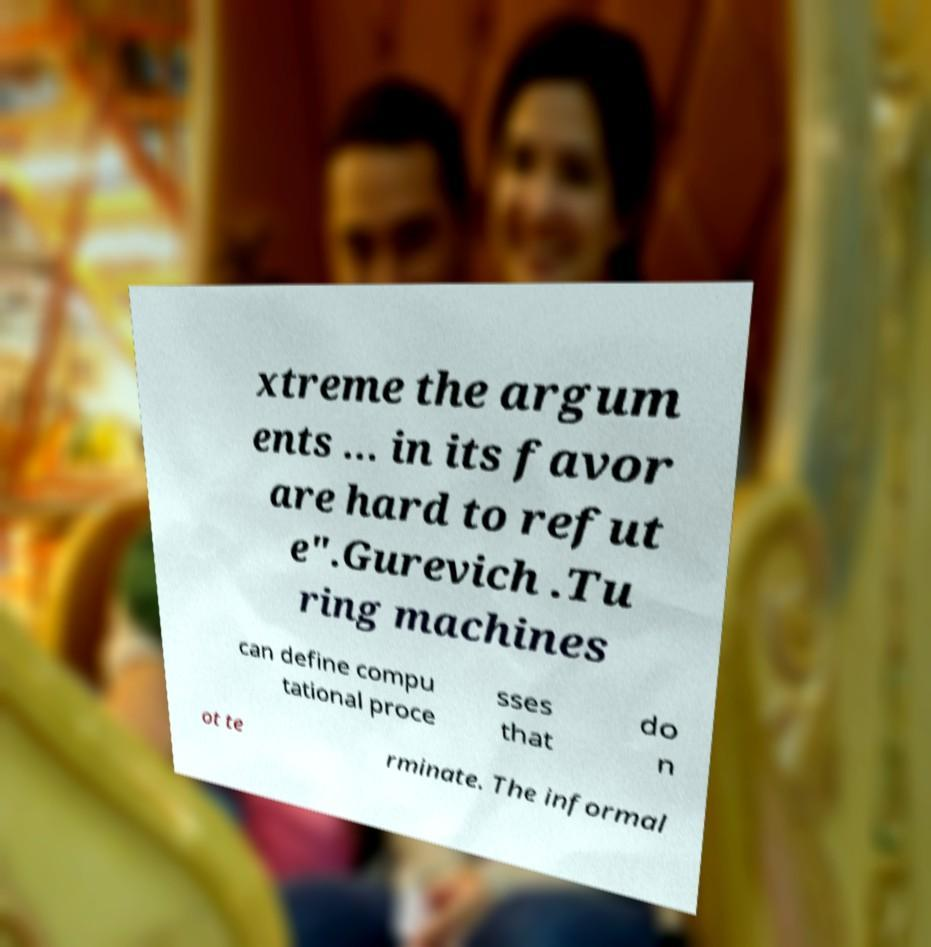Could you assist in decoding the text presented in this image and type it out clearly? xtreme the argum ents … in its favor are hard to refut e".Gurevich .Tu ring machines can define compu tational proce sses that do n ot te rminate. The informal 